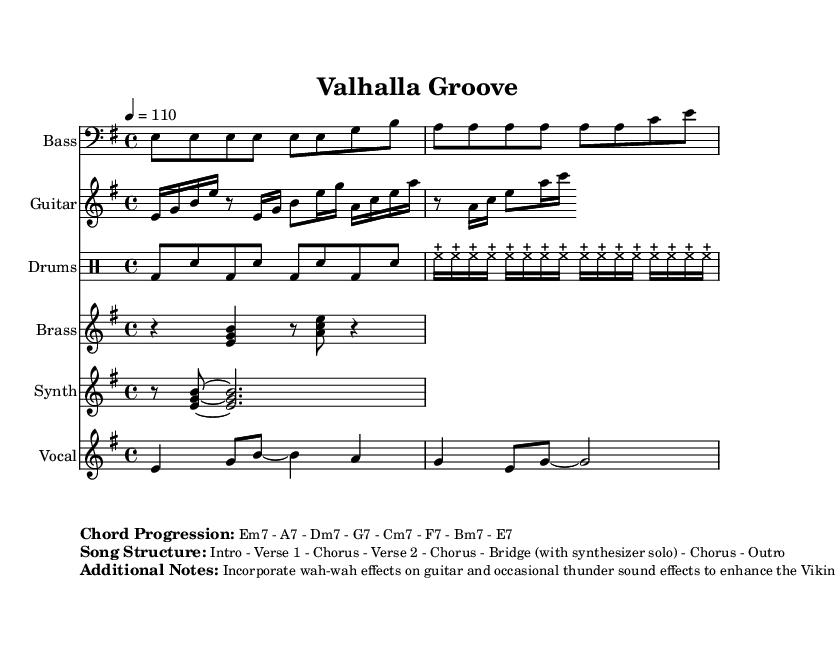What is the key signature of this music? The key signature is E minor, indicated by one sharp (F#) in the original notation. The presence of E minor can also be confirmed through the bass line which begins with the note E.
Answer: E minor What is the time signature of this music? The time signature is 4/4, which is indicated at the beginning of the score. This means there are four beats in a measure, and each quarter note gets one beat.
Answer: 4/4 What is the tempo marking for this piece? The tempo marking is a quarter note equals 110, which indicates how fast the music should be played. This is specified at the beginning of the score.
Answer: 110 How many instruments are featured in this piece? There are six instruments featured: Bass, Guitar, Drums, Brass, Synth, and Vocal. This can be determined by the different staffs and their corresponding instrument names in the score.
Answer: Six What is the chord progression listed in the sheet music? The chord progression is mentioned in the markup section, stating it is Em7 - A7 - Dm7 - G7 - Cm7 - F7 - Bm7 - E7. This indicates the sequence of chords to be played throughout the piece.
Answer: Em7 - A7 - Dm7 - G7 - Cm7 - F7 - Bm7 - E7 What is the main lyrical theme of the song? The lyrics include references to Thor and Odin, which connect to Viking mythology. This thematic element suggests a blend of funk music with Norse cultural aspects, as highlighted in the lyrics provided in the score.
Answer: Norse mythology 